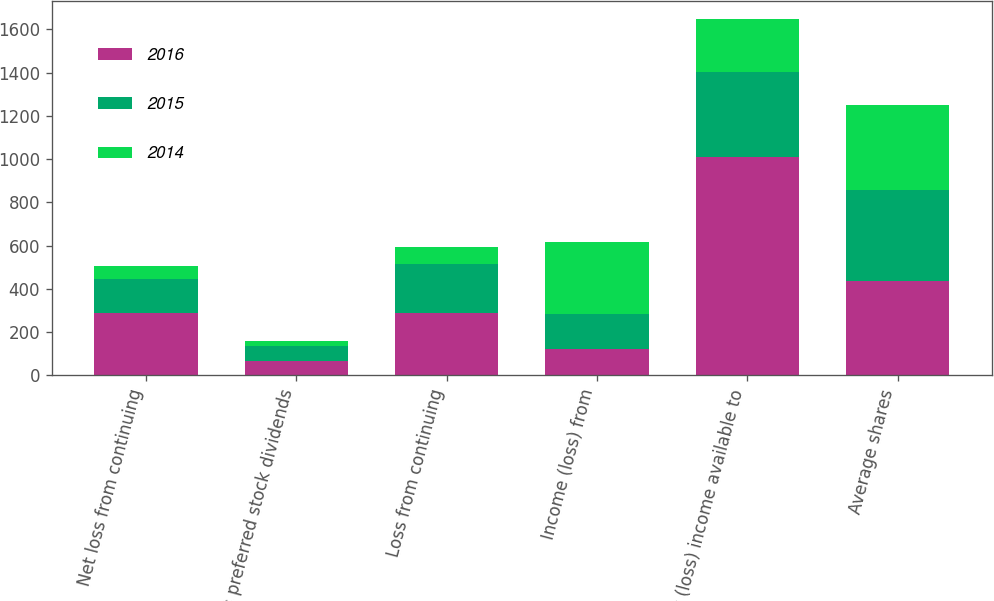Convert chart to OTSL. <chart><loc_0><loc_0><loc_500><loc_500><stacked_bar_chart><ecel><fcel>Net loss from continuing<fcel>Less preferred stock dividends<fcel>Loss from continuing<fcel>Income (loss) from<fcel>Net (loss) income available to<fcel>Average shares<nl><fcel>2016<fcel>288<fcel>69<fcel>288<fcel>121<fcel>1010<fcel>438<nl><fcel>2015<fcel>156<fcel>69<fcel>226<fcel>165<fcel>391<fcel>420<nl><fcel>2014<fcel>61<fcel>21<fcel>82<fcel>329<fcel>247<fcel>393<nl></chart> 